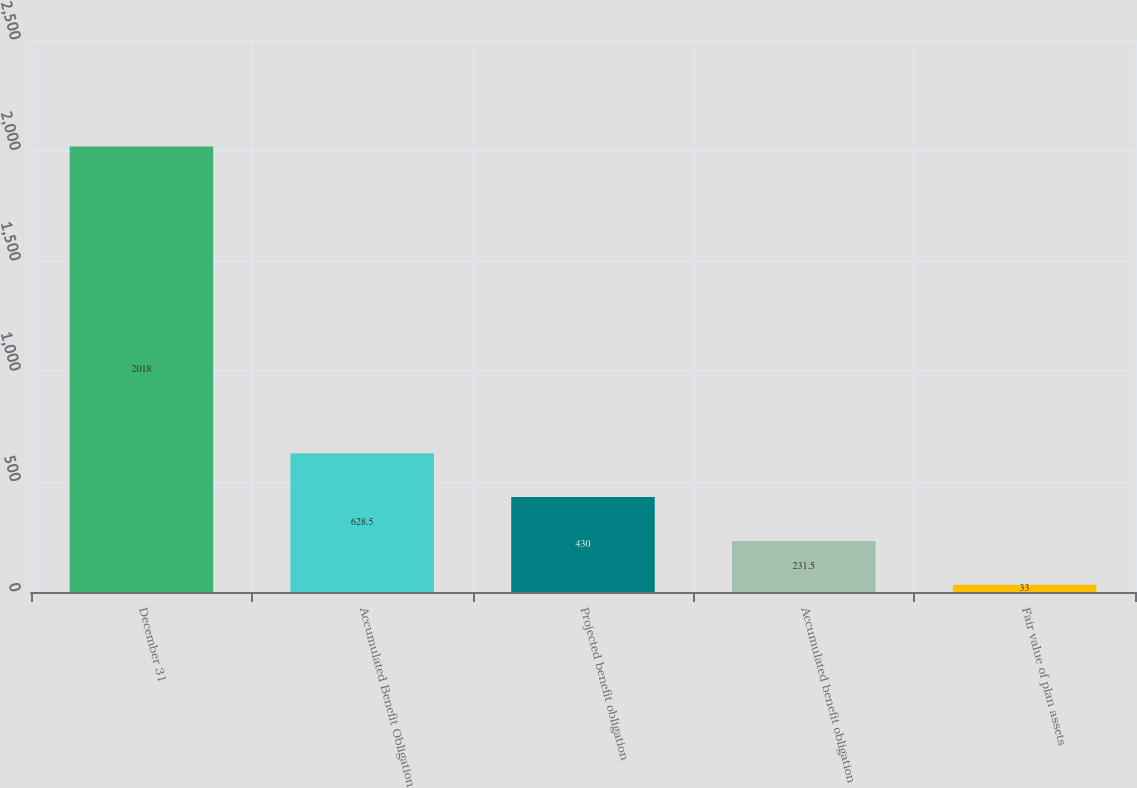<chart> <loc_0><loc_0><loc_500><loc_500><bar_chart><fcel>December 31<fcel>Accumulated Benefit Obligation<fcel>Projected benefit obligation<fcel>Accumulated benefit obligation<fcel>Fair value of plan assets<nl><fcel>2018<fcel>628.5<fcel>430<fcel>231.5<fcel>33<nl></chart> 